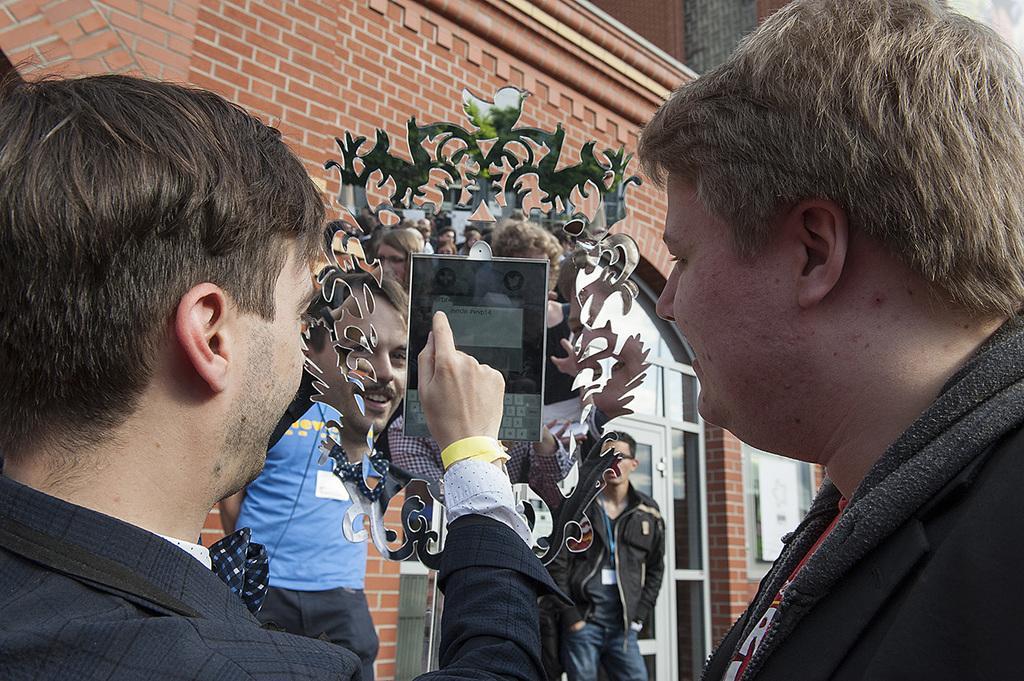Please provide a concise description of this image. This is an outside view. Here I can see two men. The man who is on the left side is pointing out at a device which is in front of these people. At the back of it there is a mirror. In the background, I can see some more people standing and there is a building and also I can see the door. 